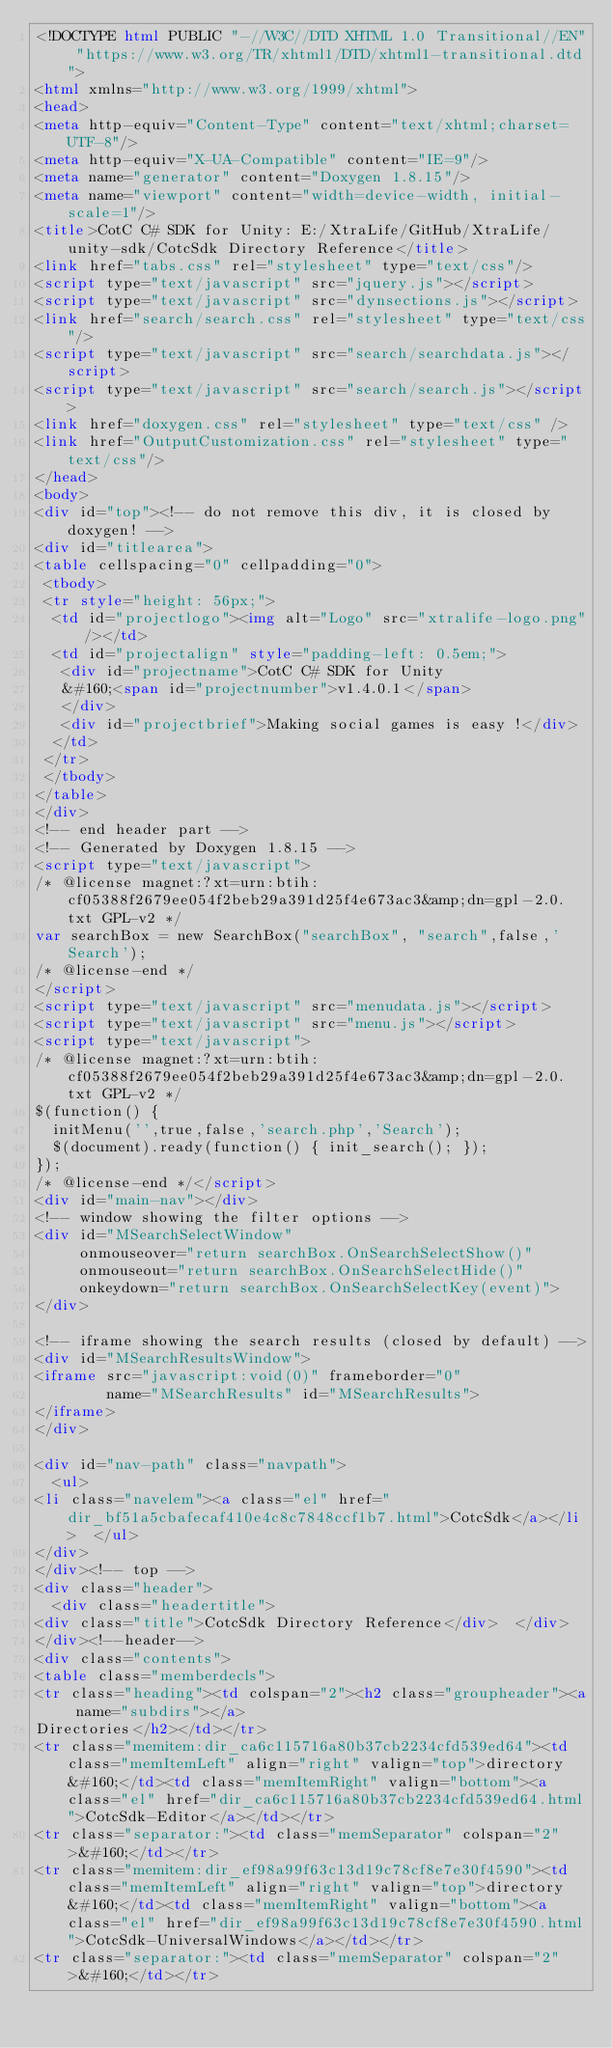<code> <loc_0><loc_0><loc_500><loc_500><_HTML_><!DOCTYPE html PUBLIC "-//W3C//DTD XHTML 1.0 Transitional//EN" "https://www.w3.org/TR/xhtml1/DTD/xhtml1-transitional.dtd">
<html xmlns="http://www.w3.org/1999/xhtml">
<head>
<meta http-equiv="Content-Type" content="text/xhtml;charset=UTF-8"/>
<meta http-equiv="X-UA-Compatible" content="IE=9"/>
<meta name="generator" content="Doxygen 1.8.15"/>
<meta name="viewport" content="width=device-width, initial-scale=1"/>
<title>CotC C# SDK for Unity: E:/XtraLife/GitHub/XtraLife/unity-sdk/CotcSdk Directory Reference</title>
<link href="tabs.css" rel="stylesheet" type="text/css"/>
<script type="text/javascript" src="jquery.js"></script>
<script type="text/javascript" src="dynsections.js"></script>
<link href="search/search.css" rel="stylesheet" type="text/css"/>
<script type="text/javascript" src="search/searchdata.js"></script>
<script type="text/javascript" src="search/search.js"></script>
<link href="doxygen.css" rel="stylesheet" type="text/css" />
<link href="OutputCustomization.css" rel="stylesheet" type="text/css"/>
</head>
<body>
<div id="top"><!-- do not remove this div, it is closed by doxygen! -->
<div id="titlearea">
<table cellspacing="0" cellpadding="0">
 <tbody>
 <tr style="height: 56px;">
  <td id="projectlogo"><img alt="Logo" src="xtralife-logo.png"/></td>
  <td id="projectalign" style="padding-left: 0.5em;">
   <div id="projectname">CotC C# SDK for Unity
   &#160;<span id="projectnumber">v1.4.0.1</span>
   </div>
   <div id="projectbrief">Making social games is easy !</div>
  </td>
 </tr>
 </tbody>
</table>
</div>
<!-- end header part -->
<!-- Generated by Doxygen 1.8.15 -->
<script type="text/javascript">
/* @license magnet:?xt=urn:btih:cf05388f2679ee054f2beb29a391d25f4e673ac3&amp;dn=gpl-2.0.txt GPL-v2 */
var searchBox = new SearchBox("searchBox", "search",false,'Search');
/* @license-end */
</script>
<script type="text/javascript" src="menudata.js"></script>
<script type="text/javascript" src="menu.js"></script>
<script type="text/javascript">
/* @license magnet:?xt=urn:btih:cf05388f2679ee054f2beb29a391d25f4e673ac3&amp;dn=gpl-2.0.txt GPL-v2 */
$(function() {
  initMenu('',true,false,'search.php','Search');
  $(document).ready(function() { init_search(); });
});
/* @license-end */</script>
<div id="main-nav"></div>
<!-- window showing the filter options -->
<div id="MSearchSelectWindow"
     onmouseover="return searchBox.OnSearchSelectShow()"
     onmouseout="return searchBox.OnSearchSelectHide()"
     onkeydown="return searchBox.OnSearchSelectKey(event)">
</div>

<!-- iframe showing the search results (closed by default) -->
<div id="MSearchResultsWindow">
<iframe src="javascript:void(0)" frameborder="0" 
        name="MSearchResults" id="MSearchResults">
</iframe>
</div>

<div id="nav-path" class="navpath">
  <ul>
<li class="navelem"><a class="el" href="dir_bf51a5cbafecaf410e4c8c7848ccf1b7.html">CotcSdk</a></li>  </ul>
</div>
</div><!-- top -->
<div class="header">
  <div class="headertitle">
<div class="title">CotcSdk Directory Reference</div>  </div>
</div><!--header-->
<div class="contents">
<table class="memberdecls">
<tr class="heading"><td colspan="2"><h2 class="groupheader"><a name="subdirs"></a>
Directories</h2></td></tr>
<tr class="memitem:dir_ca6c115716a80b37cb2234cfd539ed64"><td class="memItemLeft" align="right" valign="top">directory &#160;</td><td class="memItemRight" valign="bottom"><a class="el" href="dir_ca6c115716a80b37cb2234cfd539ed64.html">CotcSdk-Editor</a></td></tr>
<tr class="separator:"><td class="memSeparator" colspan="2">&#160;</td></tr>
<tr class="memitem:dir_ef98a99f63c13d19c78cf8e7e30f4590"><td class="memItemLeft" align="right" valign="top">directory &#160;</td><td class="memItemRight" valign="bottom"><a class="el" href="dir_ef98a99f63c13d19c78cf8e7e30f4590.html">CotcSdk-UniversalWindows</a></td></tr>
<tr class="separator:"><td class="memSeparator" colspan="2">&#160;</td></tr></code> 